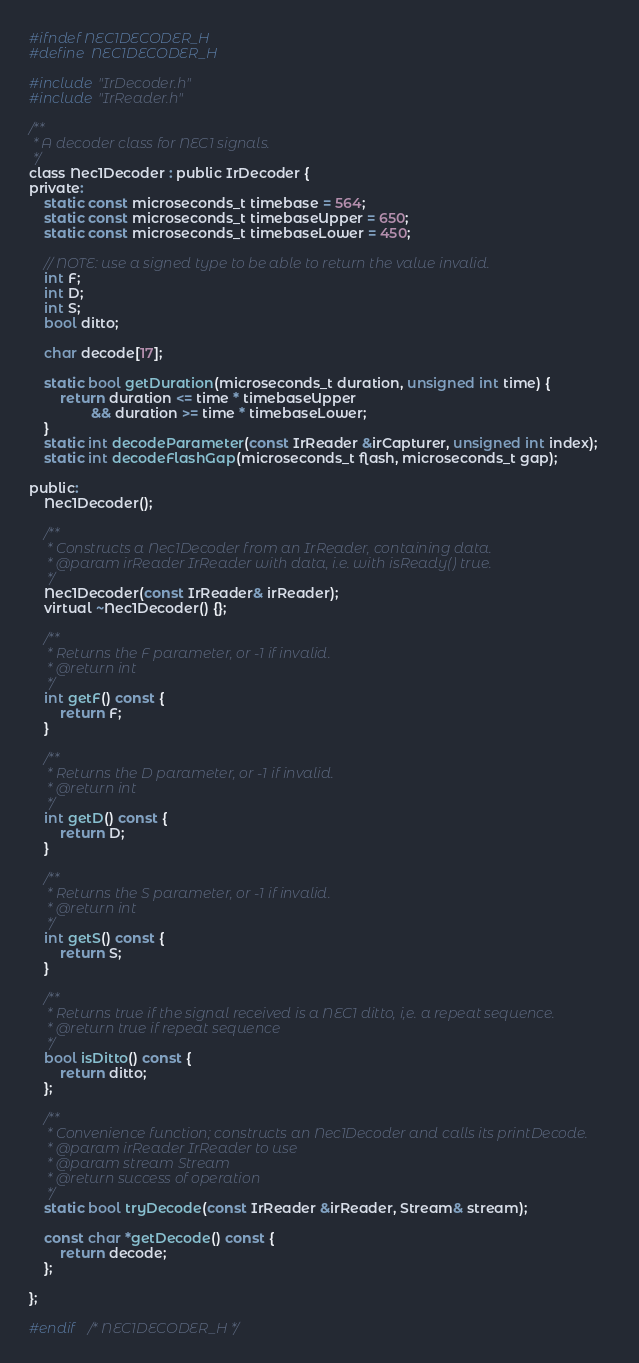<code> <loc_0><loc_0><loc_500><loc_500><_C_>#ifndef NEC1DECODER_H
#define	NEC1DECODER_H

#include "IrDecoder.h"
#include "IrReader.h"

/**
 * A decoder class for NEC1 signals.
 */
class Nec1Decoder : public IrDecoder {
private:
    static const microseconds_t timebase = 564;
    static const microseconds_t timebaseUpper = 650;
    static const microseconds_t timebaseLower = 450;

    // NOTE: use a signed type to be able to return the value invalid.
    int F;
    int D;
    int S;
    bool ditto;

    char decode[17];

    static bool getDuration(microseconds_t duration, unsigned int time) {
        return duration <= time * timebaseUpper
                && duration >= time * timebaseLower;
    }
    static int decodeParameter(const IrReader &irCapturer, unsigned int index);
    static int decodeFlashGap(microseconds_t flash, microseconds_t gap);

public:
    Nec1Decoder();

    /**
     * Constructs a Nec1Decoder from an IrReader, containing data.
     * @param irReader IrReader with data, i.e. with isReady() true.
     */
    Nec1Decoder(const IrReader& irReader);
    virtual ~Nec1Decoder() {};

    /**
     * Returns the F parameter, or -1 if invalid.
     * @return int
     */
    int getF() const {
        return F;
    }

    /**
     * Returns the D parameter, or -1 if invalid.
     * @return int
     */
    int getD() const {
        return D;
    }

    /**
     * Returns the S parameter, or -1 if invalid.
     * @return int
     */
    int getS() const {
        return S;
    }

    /**
     * Returns true if the signal received is a NEC1 ditto, i,e. a repeat sequence.
     * @return true if repeat sequence
     */
    bool isDitto() const {
        return ditto;
    };

    /**
     * Convenience function; constructs an Nec1Decoder and calls its printDecode.
     * @param irReader IrReader to use
     * @param stream Stream
     * @return success of operation
     */
    static bool tryDecode(const IrReader &irReader, Stream& stream);

    const char *getDecode() const {
        return decode;
    };

};

#endif	/* NEC1DECODER_H */
</code> 